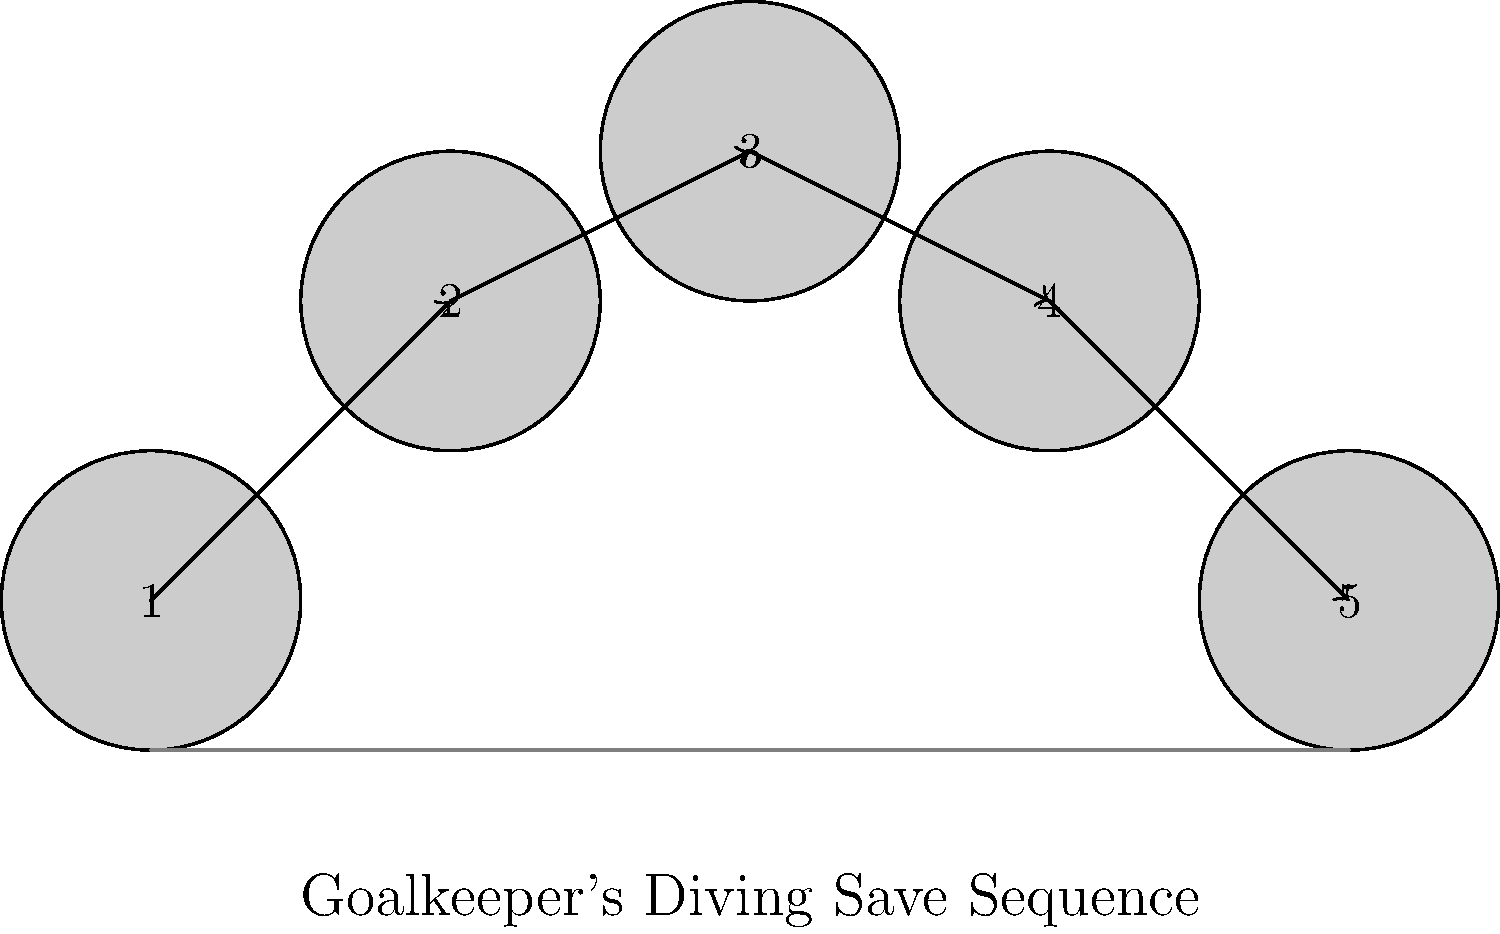Analyze the sequence of freeze-frame images depicting a goalkeeper's diving save. Which number represents the apex of the dive, where the goalkeeper is at the highest point and fully extended? To determine the apex of the goalkeeper's diving save, let's analyze the sequence step by step:

1. Position 1: The goalkeeper is in the starting position, likely reacting to the shot.
2. Position 2: The goalkeeper has begun to dive, leaving the ground and moving upward.
3. Position 3: This appears to be the highest point of the dive. The goalkeeper is fully extended and at the maximum height.
4. Position 4: The goalkeeper is descending, having passed the apex of the dive.
5. Position 5: The goalkeeper has landed on the ground, completing the diving motion.

The apex of the dive is the point where the goalkeeper reaches the highest elevation and full extension. This occurs at position 3 in the sequence.
Answer: 3 